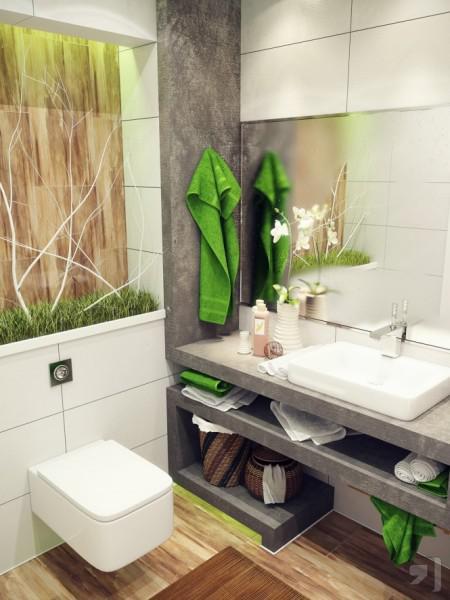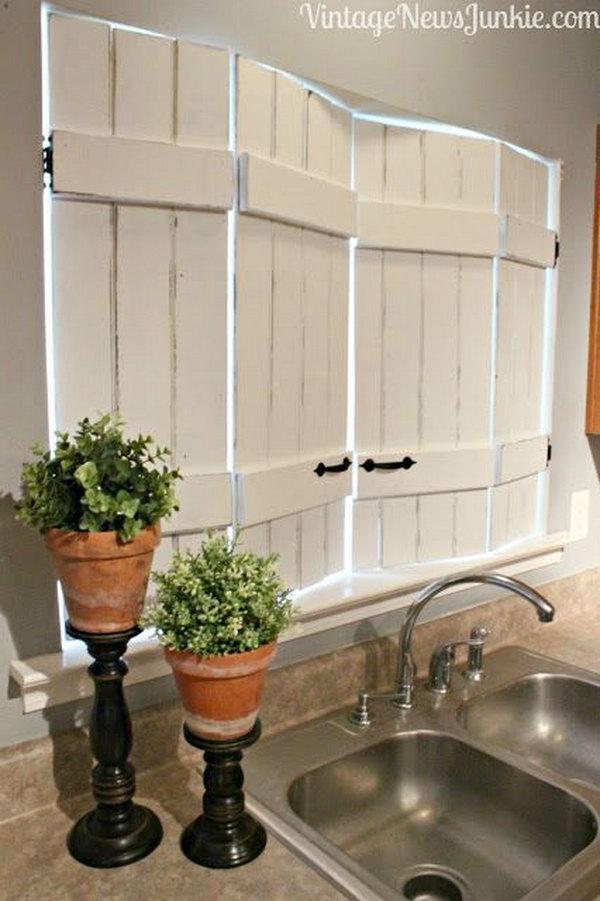The first image is the image on the left, the second image is the image on the right. Evaluate the accuracy of this statement regarding the images: "An image shows a stainless steel, double basin sink with plants nearby.". Is it true? Answer yes or no. Yes. 